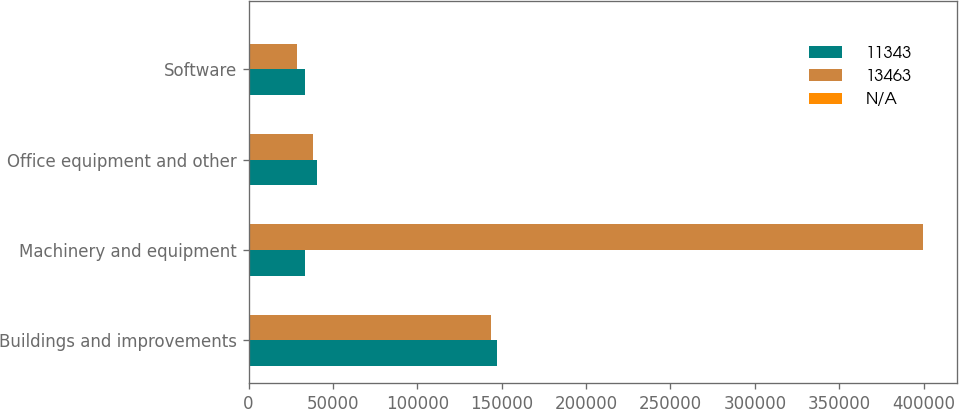<chart> <loc_0><loc_0><loc_500><loc_500><stacked_bar_chart><ecel><fcel>Buildings and improvements<fcel>Machinery and equipment<fcel>Office equipment and other<fcel>Software<nl><fcel>11343<fcel>147114<fcel>33336<fcel>40380<fcel>33336<nl><fcel>13463<fcel>143503<fcel>399730<fcel>38254<fcel>28479<nl><fcel>nan<fcel>940<fcel>320<fcel>310<fcel>5<nl></chart> 